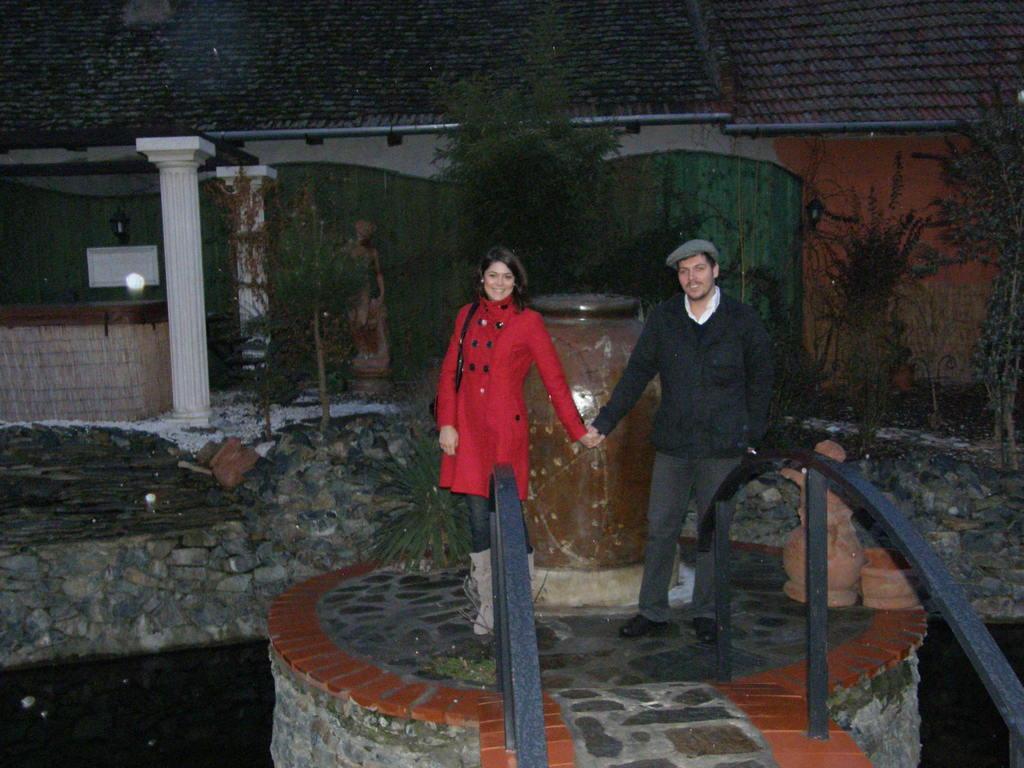Please provide a concise description of this image. In this image I can see a woman wearing red colored dress and a man wearing black jacket, jeans and black shoe are standing and holding hands. I can see the black colored railing. In the background I can see few trees and the building. 